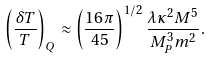Convert formula to latex. <formula><loc_0><loc_0><loc_500><loc_500>\left ( \frac { \delta T } { T } \right ) _ { Q } \approx \left ( \frac { 1 6 \pi } { 4 5 } \right ) ^ { 1 / 2 } \frac { \lambda \kappa ^ { 2 } M ^ { 5 } } { M ^ { 3 } _ { P } m ^ { 2 } } .</formula> 